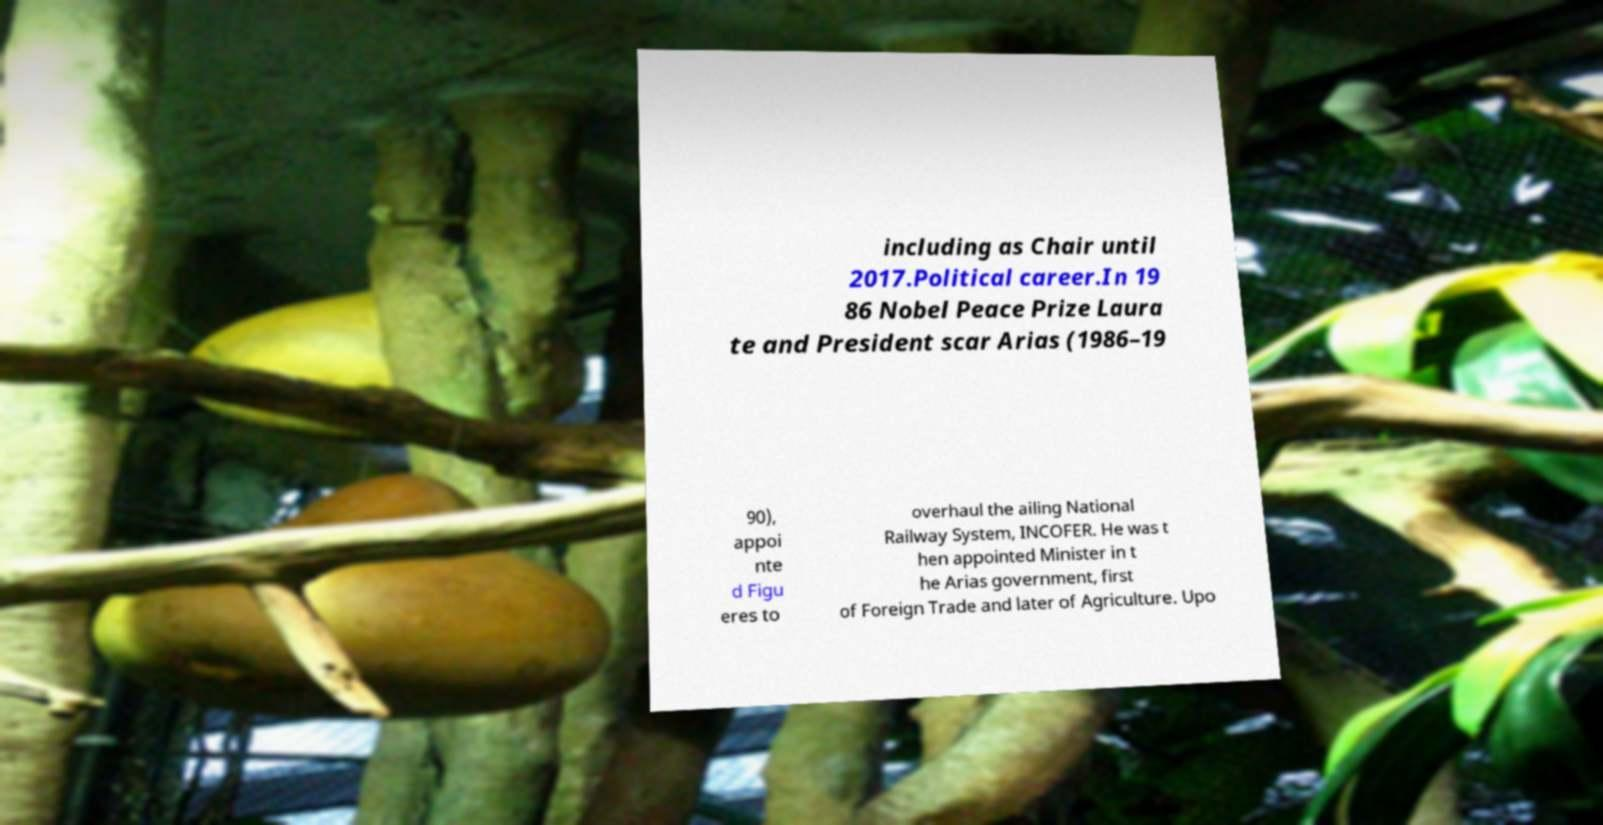Could you extract and type out the text from this image? including as Chair until 2017.Political career.In 19 86 Nobel Peace Prize Laura te and President scar Arias (1986–19 90), appoi nte d Figu eres to overhaul the ailing National Railway System, INCOFER. He was t hen appointed Minister in t he Arias government, first of Foreign Trade and later of Agriculture. Upo 